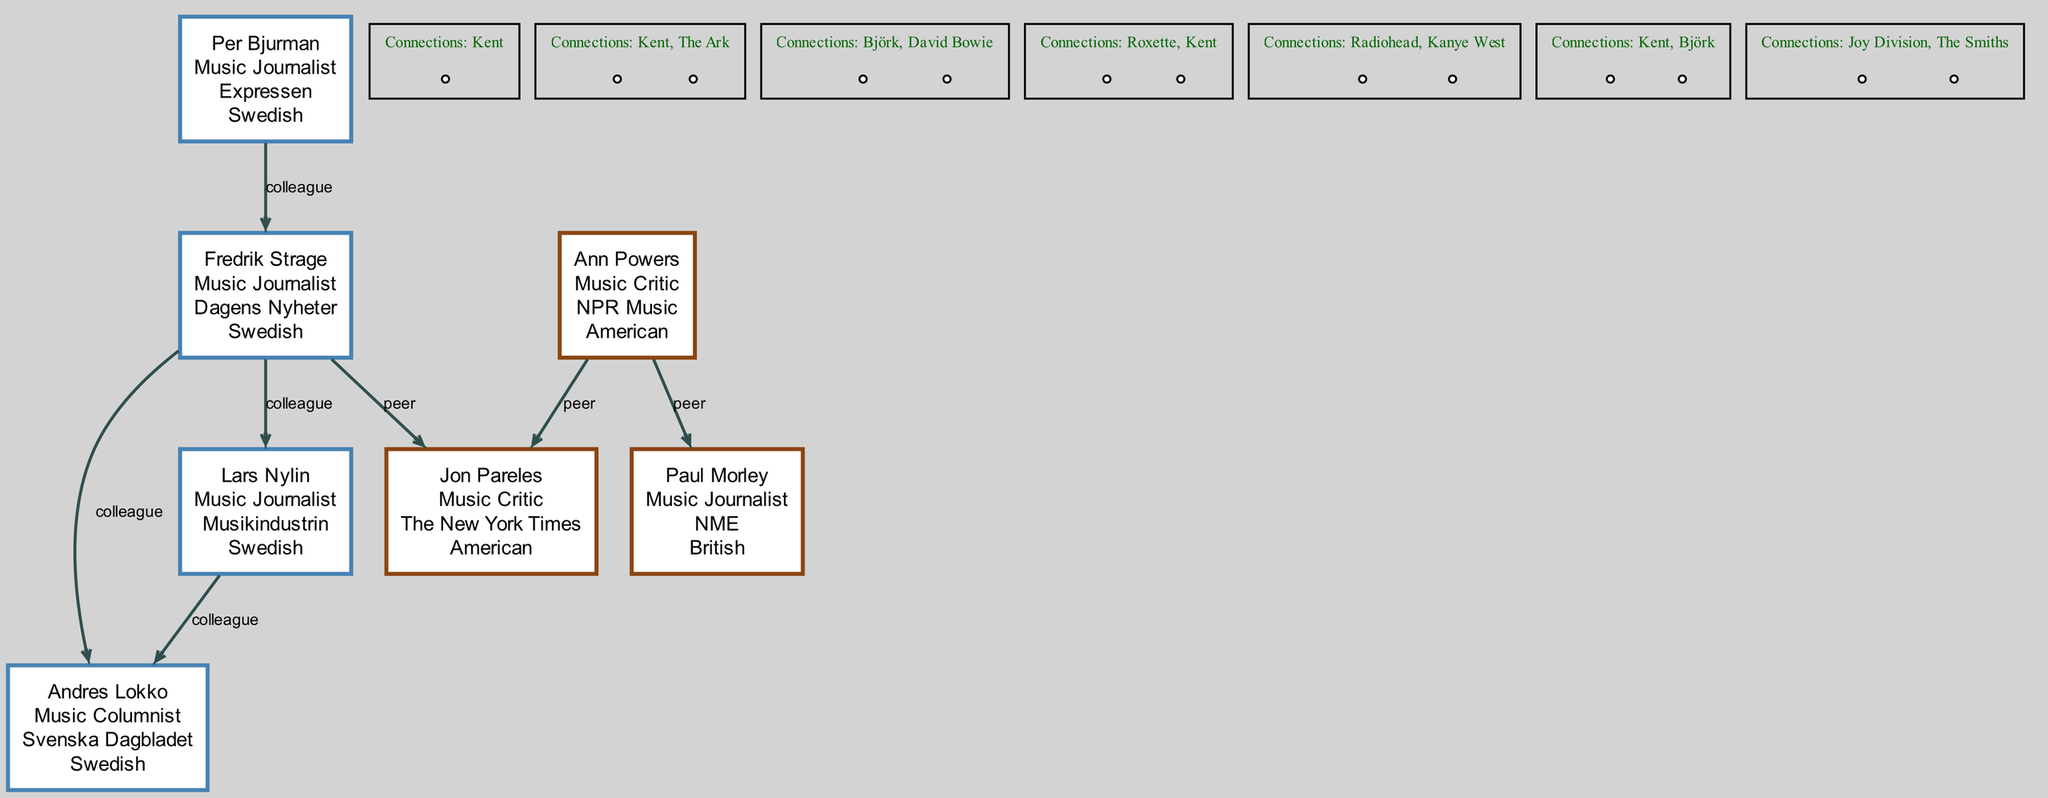What is the profession of Per Bjurman? The diagram labels Per Bjurman as a "Music Journalist" in the corresponding node.
Answer: Music Journalist Which publication is Fredrik Strage known for? In the diagram, Fredrik Strage is indicated as being known for "Dagens Nyheter," which is specified in his node.
Answer: Dagens Nyheter How many connections does Lars Nylin have? By examining Lars Nylin's node, it lists two connections: "Roxette" and "Kent." Therefore, he has 2 connections.
Answer: 2 Who is connected to Kent and works at Svenska Dagbladet? Looking at the nodes, Andres Lokko is the only one identified with a connection to "Kent" and is known for his work at "Svenska Dagbladet."
Answer: Andres Lokko Which two music critics are peers in the diagram? The diagram directly indicates that Jon Pareles and Ann Powers are peers, as there is an edge connecting their nodes labeled as "peer."
Answer: Jon Pareles and Ann Powers What type of connection exists between Per Bjurman and Fredrik Strage? The diagram specifies that the line between Per Bjurman and Fredrik Strage is labeled as "colleague," indicating their relationship type.
Answer: colleague Which nationality is Ann Powers? The node for Ann Powers in the diagram lists "American" as her nationality, providing a straightforward answer to this question.
Answer: American How many Swedish journalists are depicted in the diagram? By reviewing the nodes, Per Bjurman, Fredrik Strage, Lars Nylin, and Andres Lokko are identified as Swedish, totaling four.
Answer: 4 Which musician is associated with Paul Morley? The diagram identifies Joy Division as one of the connections for Paul Morley, making it clear which musician is associated with him.
Answer: Joy Division 